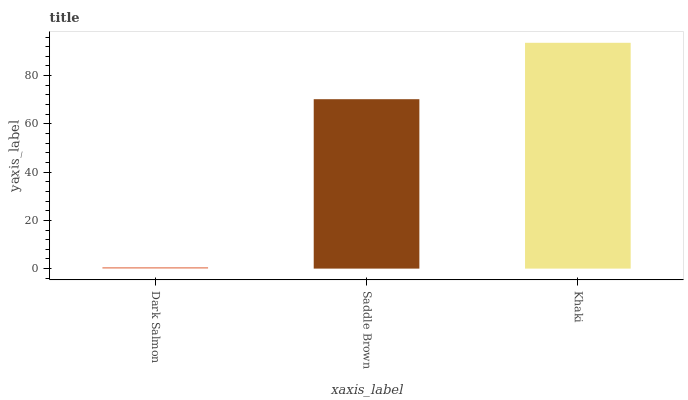Is Dark Salmon the minimum?
Answer yes or no. Yes. Is Khaki the maximum?
Answer yes or no. Yes. Is Saddle Brown the minimum?
Answer yes or no. No. Is Saddle Brown the maximum?
Answer yes or no. No. Is Saddle Brown greater than Dark Salmon?
Answer yes or no. Yes. Is Dark Salmon less than Saddle Brown?
Answer yes or no. Yes. Is Dark Salmon greater than Saddle Brown?
Answer yes or no. No. Is Saddle Brown less than Dark Salmon?
Answer yes or no. No. Is Saddle Brown the high median?
Answer yes or no. Yes. Is Saddle Brown the low median?
Answer yes or no. Yes. Is Khaki the high median?
Answer yes or no. No. Is Khaki the low median?
Answer yes or no. No. 